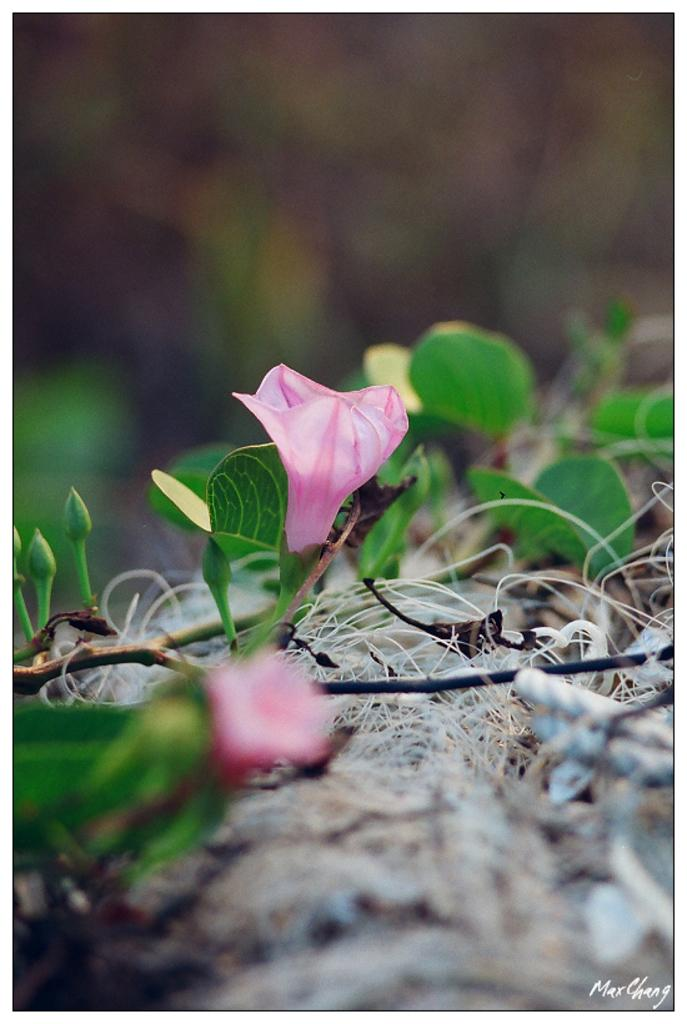What type of plants can be seen in the image? There are flowers in the image. What stage of growth are the plants in? There are buds on the plants in the image. How many dogs can be seen sneezing in the image? There are no dogs present in the image, and therefore no sneezing can be observed. 